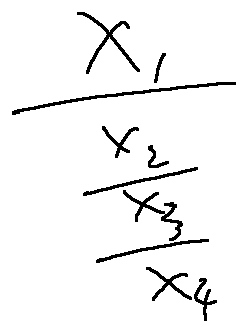<formula> <loc_0><loc_0><loc_500><loc_500>\frac { x _ { 1 } } { \frac { x _ { 2 } } { \frac { x _ { 3 } } { x _ { 4 } } } }</formula> 